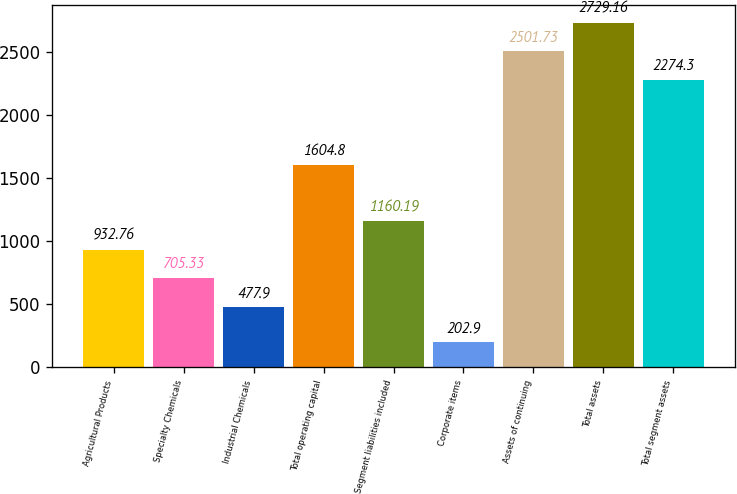<chart> <loc_0><loc_0><loc_500><loc_500><bar_chart><fcel>Agricultural Products<fcel>Specialty Chemicals<fcel>Industrial Chemicals<fcel>Total operating capital<fcel>Segment liabilities included<fcel>Corporate items<fcel>Assets of continuing<fcel>Total assets<fcel>Total segment assets<nl><fcel>932.76<fcel>705.33<fcel>477.9<fcel>1604.8<fcel>1160.19<fcel>202.9<fcel>2501.73<fcel>2729.16<fcel>2274.3<nl></chart> 